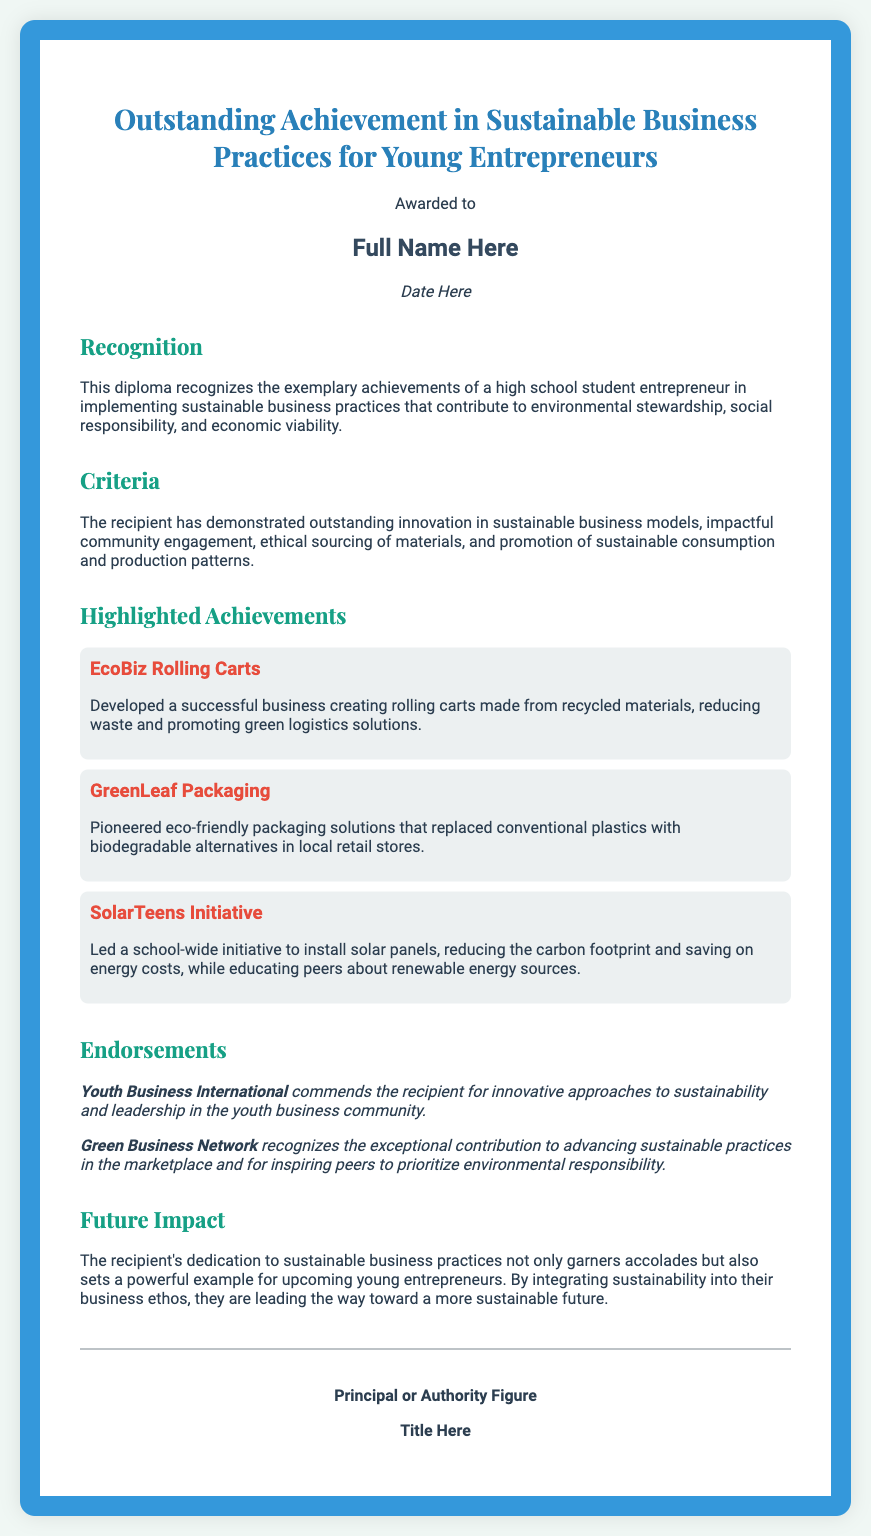what is the title of the diploma? The title of the diploma is the main heading that indicates its purpose.
Answer: Outstanding Achievement in Sustainable Business Practices for Young Entrepreneurs who is the recipient of the diploma? The recipient's name would be displayed where it says "Full Name Here."
Answer: Full Name Here what is the date printed on the diploma? The date would be shown in the section labeled "Date Here."
Answer: Date Here how many highlighted achievements are listed? The document includes a section that lists various achievements, and there are three achievements mentioned.
Answer: 3 what is the title of the first highlighted achievement? The title of the first achievement is the name given to it in bold.
Answer: EcoBiz Rolling Carts what organization commends the recipient for innovative approaches? The organization mentioned recognizes the recipient's efforts and is stated in the endorsement section.
Answer: Youth Business International what is a key theme of the future impact section? The future impact section discusses the long-term effects of the recipient's actions and contributions.
Answer: Sustainability what does the recipient lead in the highlighted achievement "SolarTeens Initiative"? The description specifies what the recipient's leadership involved regarding solar energy.
Answer: School-wide initiative to install solar panels who provides the signature at the bottom of the diploma? The signature is expected to be from an authority figure responsible for the award.
Answer: Principal or Authority Figure 